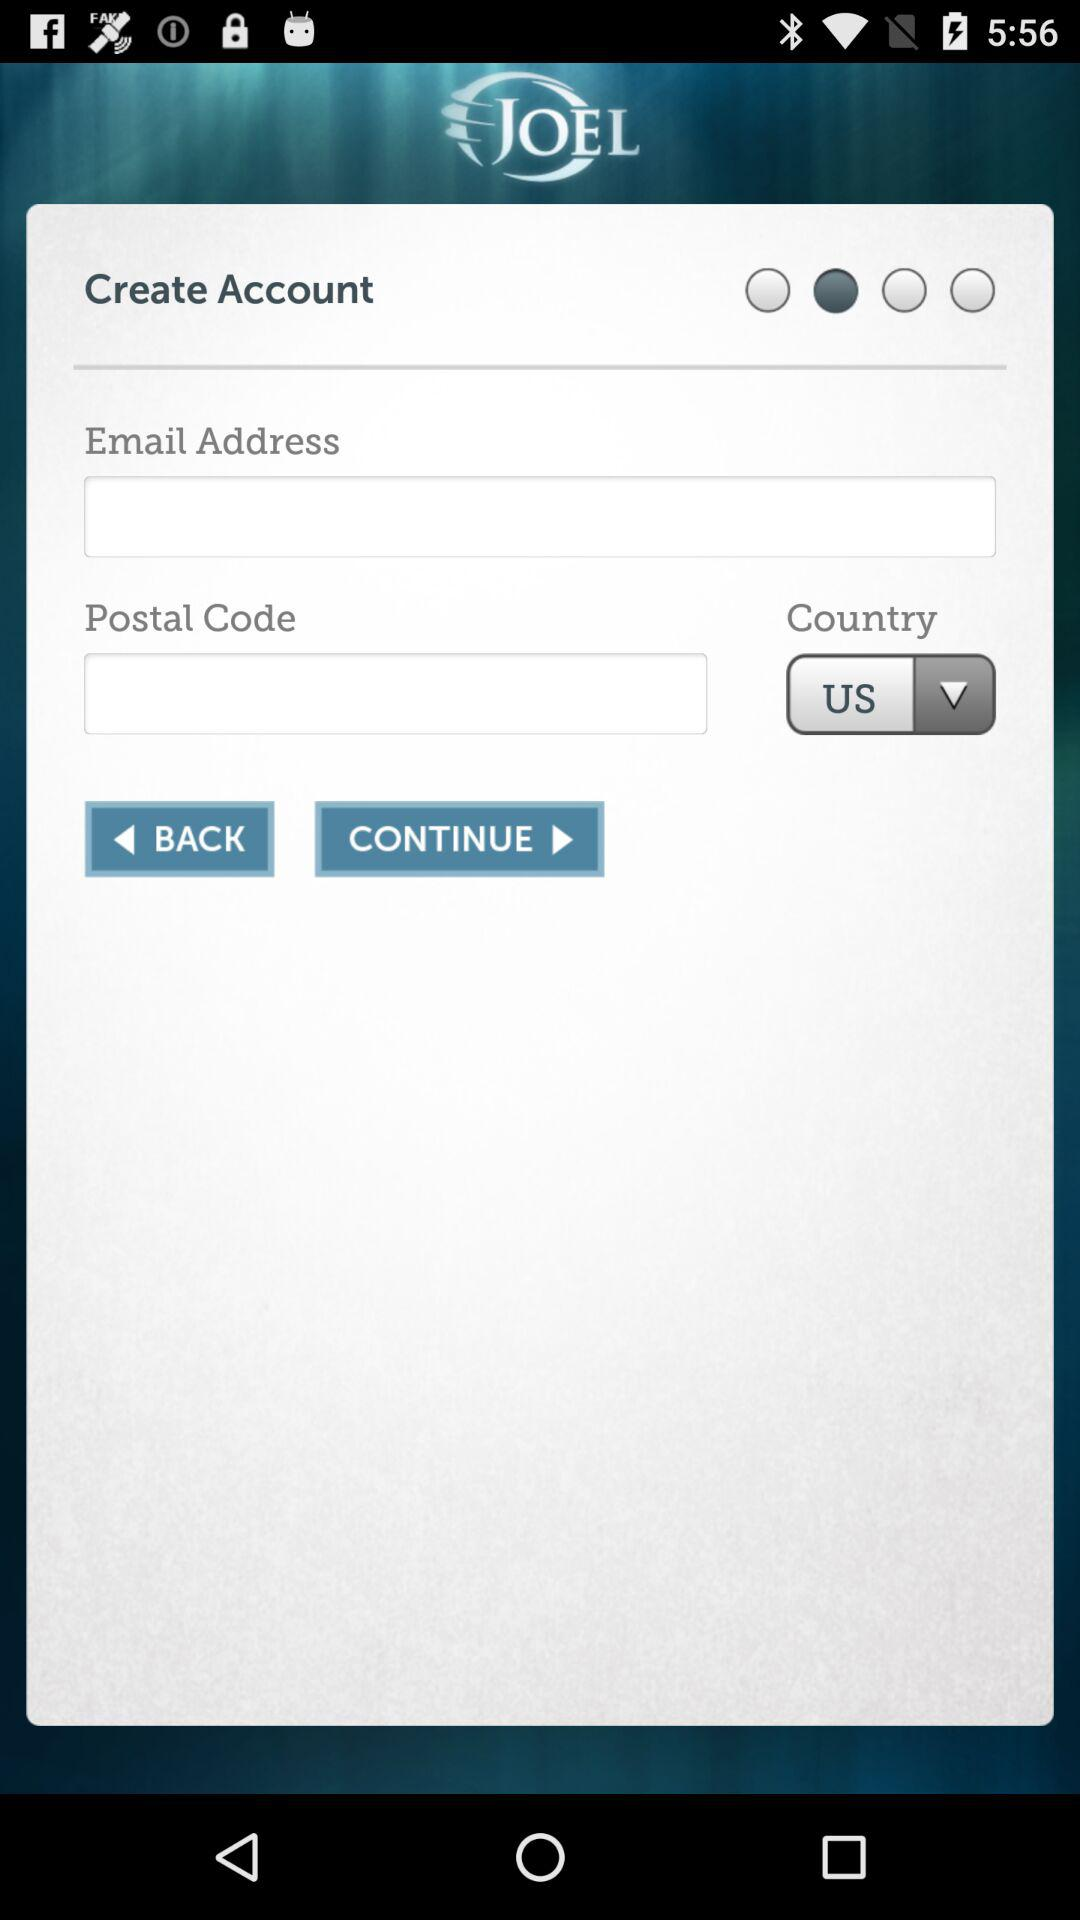What is the selected country? The selected country is the US. 